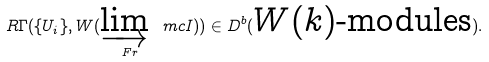Convert formula to latex. <formula><loc_0><loc_0><loc_500><loc_500>R \Gamma ( \{ U _ { i } \} , W ( \varinjlim _ { \ F r } \ m c { I } ) ) \in D ^ { b } ( \text {$W(k)$-modules} ) .</formula> 